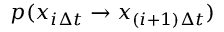Convert formula to latex. <formula><loc_0><loc_0><loc_500><loc_500>p ( x _ { i \Delta t } \to x _ { ( i + 1 ) \Delta t } )</formula> 